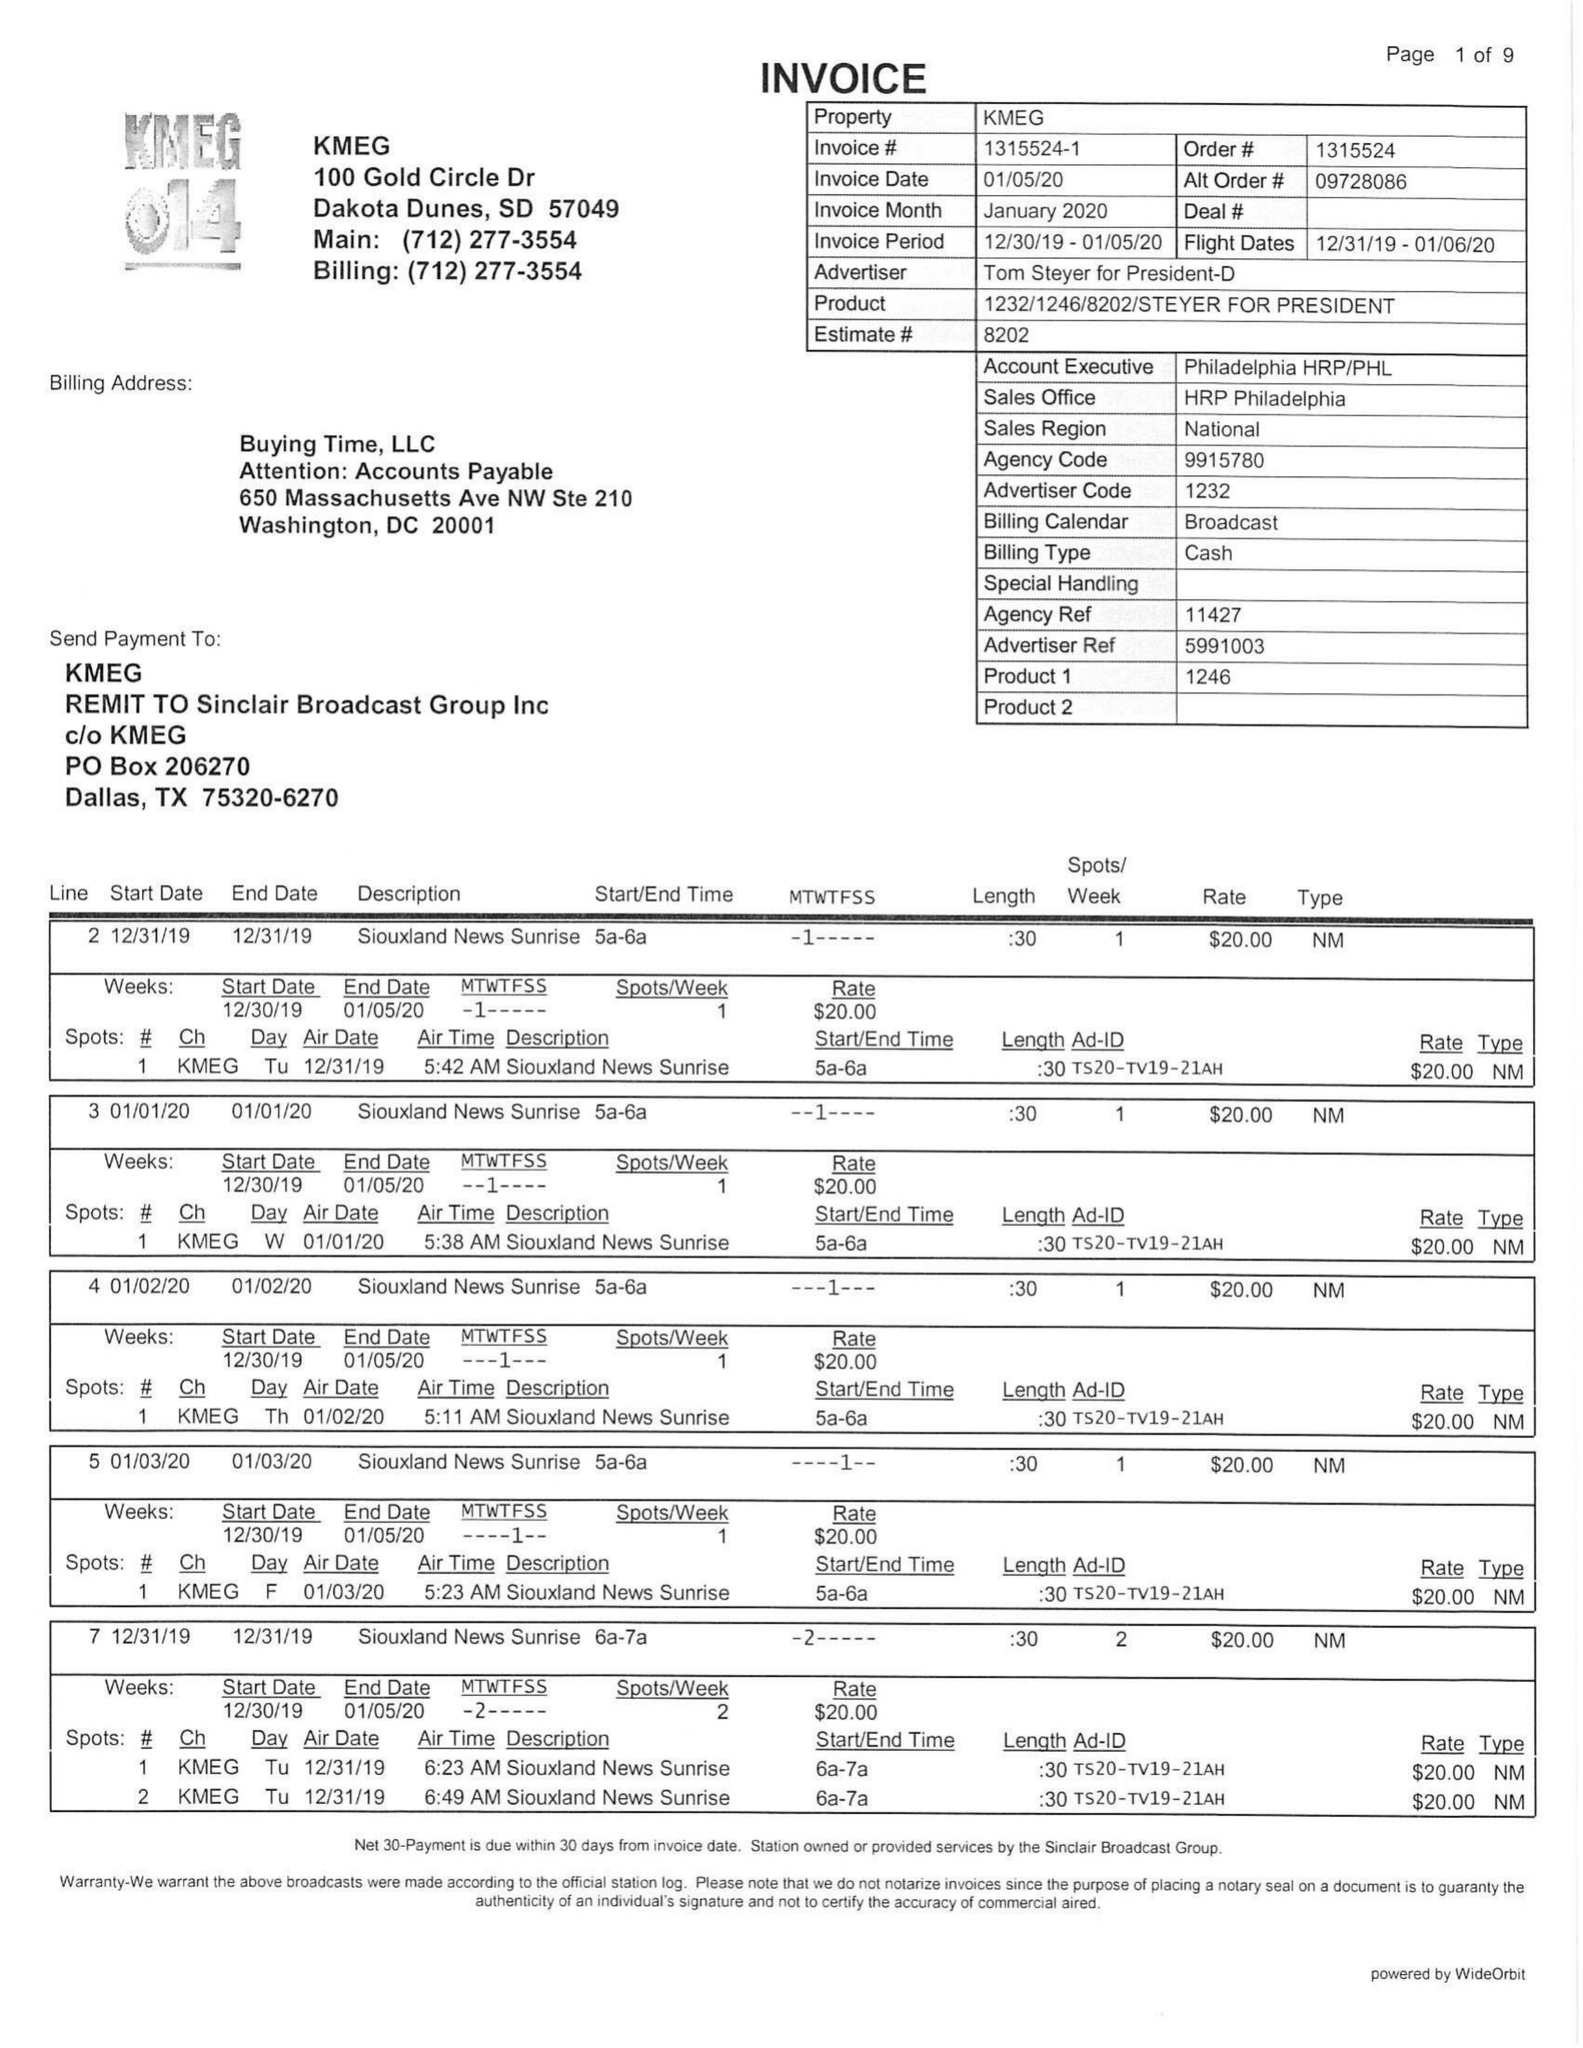What is the value for the flight_from?
Answer the question using a single word or phrase. 12/31/19 